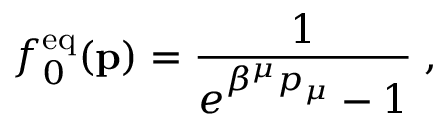<formula> <loc_0><loc_0><loc_500><loc_500>f _ { 0 } ^ { e q } ( { p } ) = { \frac { 1 } { e ^ { \beta ^ { \mu } p _ { \mu } } - 1 } } \, ,</formula> 